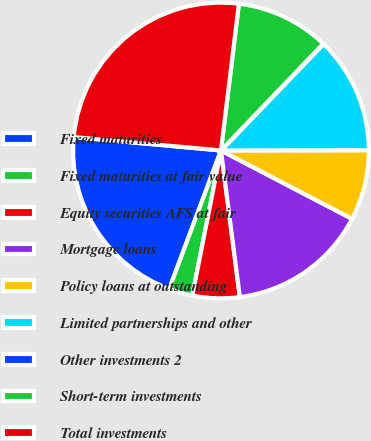Convert chart. <chart><loc_0><loc_0><loc_500><loc_500><pie_chart><fcel>Fixed maturities<fcel>Fixed maturities at fair value<fcel>Equity securities AFS at fair<fcel>Mortgage loans<fcel>Policy loans at outstanding<fcel>Limited partnerships and other<fcel>Other investments 2<fcel>Short-term investments<fcel>Total investments<nl><fcel>20.75%<fcel>2.59%<fcel>5.14%<fcel>15.31%<fcel>7.68%<fcel>12.77%<fcel>0.05%<fcel>10.22%<fcel>25.49%<nl></chart> 